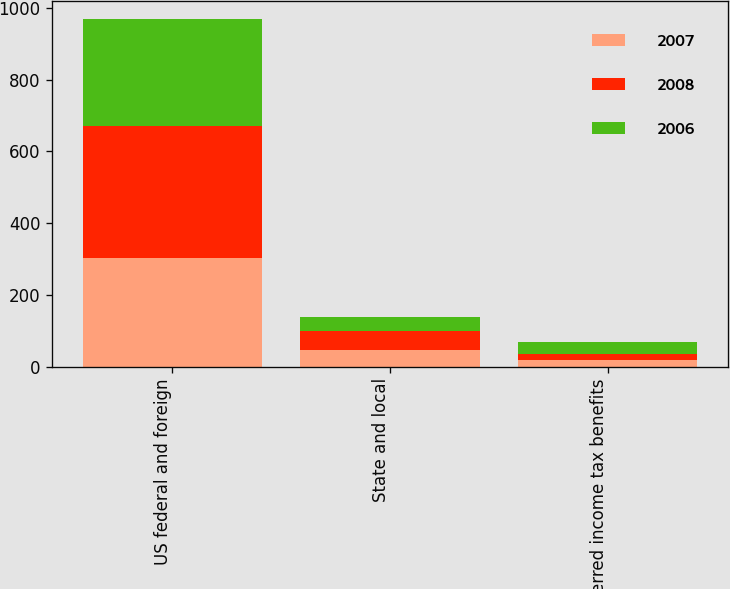<chart> <loc_0><loc_0><loc_500><loc_500><stacked_bar_chart><ecel><fcel>US federal and foreign<fcel>State and local<fcel>Deferred income tax benefits<nl><fcel>2007<fcel>301.9<fcel>45.8<fcel>19<nl><fcel>2008<fcel>368.6<fcel>53.3<fcel>15.7<nl><fcel>2006<fcel>299.5<fcel>39.3<fcel>33.4<nl></chart> 